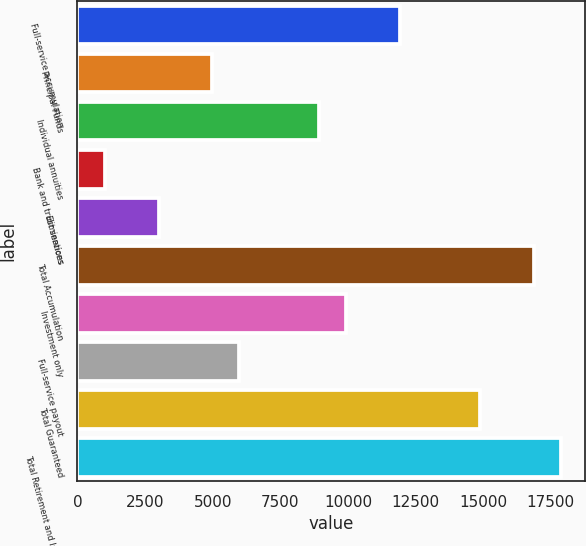Convert chart to OTSL. <chart><loc_0><loc_0><loc_500><loc_500><bar_chart><fcel>Full-service accumulation<fcel>Principal Funds<fcel>Individual annuities<fcel>Bank and trust services<fcel>Eliminations<fcel>Total Accumulation<fcel>Investment only<fcel>Full-service payout<fcel>Total Guaranteed<fcel>Total Retirement and Investor<nl><fcel>11916.6<fcel>4984.05<fcel>8945.53<fcel>1022.57<fcel>3003.31<fcel>16868.5<fcel>9935.9<fcel>5974.42<fcel>14887.8<fcel>17858.9<nl></chart> 